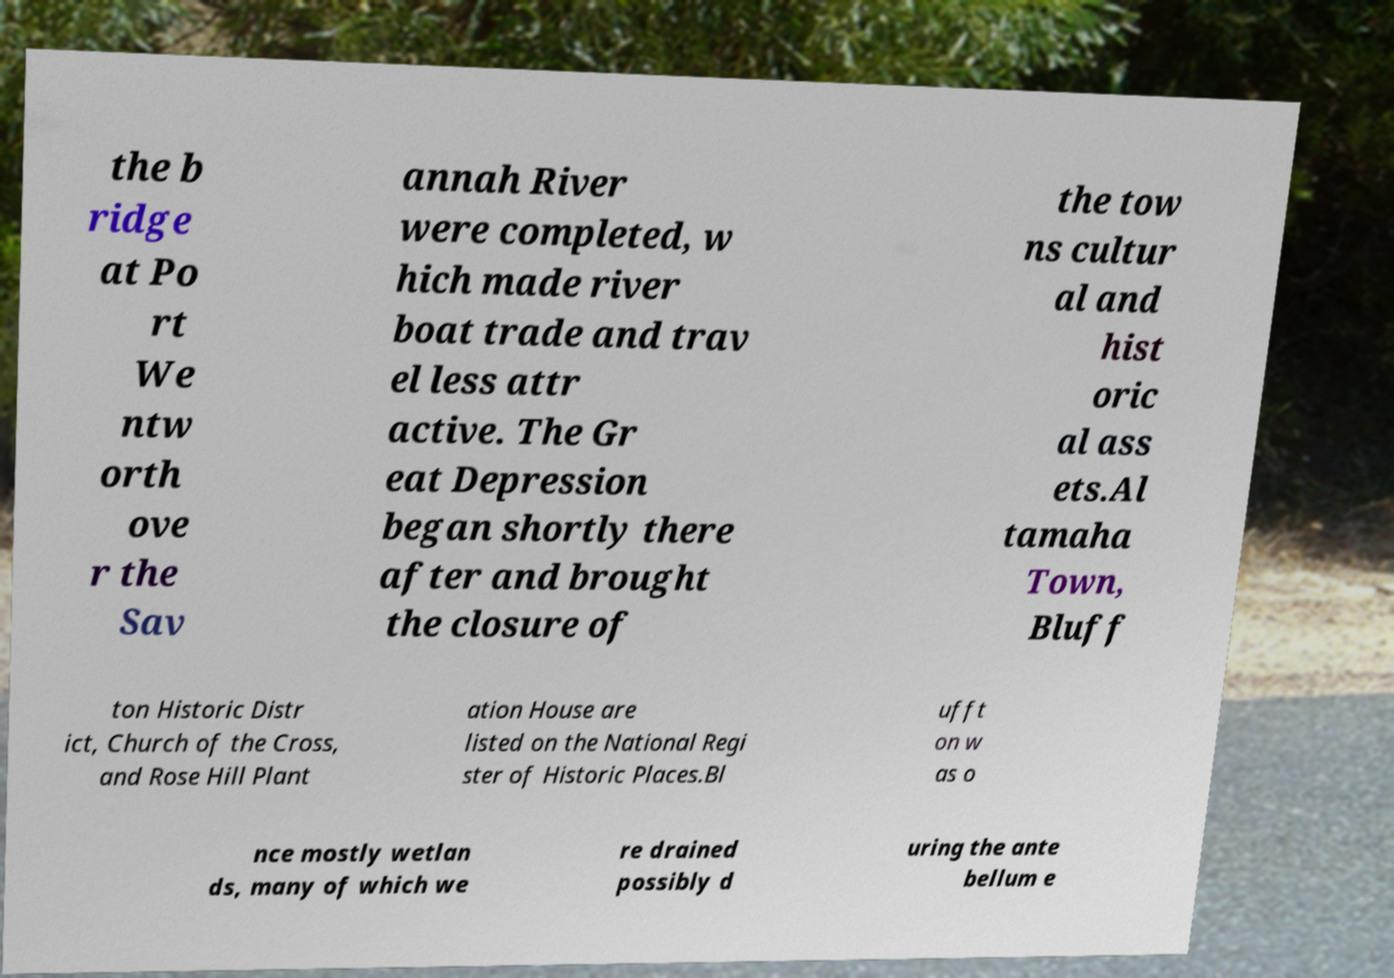Can you accurately transcribe the text from the provided image for me? the b ridge at Po rt We ntw orth ove r the Sav annah River were completed, w hich made river boat trade and trav el less attr active. The Gr eat Depression began shortly there after and brought the closure of the tow ns cultur al and hist oric al ass ets.Al tamaha Town, Bluff ton Historic Distr ict, Church of the Cross, and Rose Hill Plant ation House are listed on the National Regi ster of Historic Places.Bl ufft on w as o nce mostly wetlan ds, many of which we re drained possibly d uring the ante bellum e 